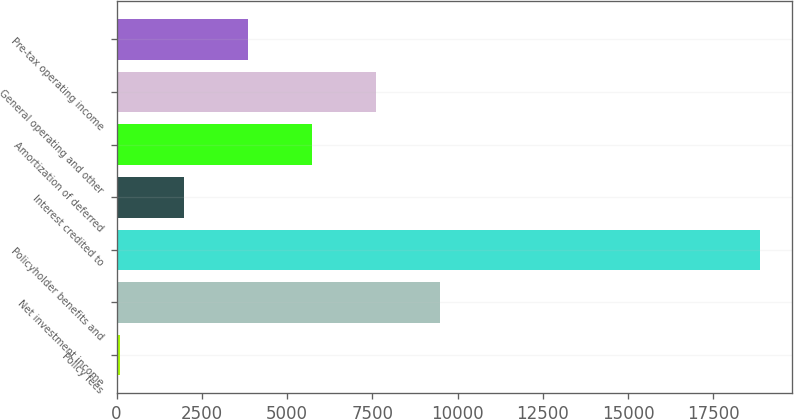<chart> <loc_0><loc_0><loc_500><loc_500><bar_chart><fcel>Policy fees<fcel>Net investment income<fcel>Policyholder benefits and<fcel>Interest credited to<fcel>Amortization of deferred<fcel>General operating and other<fcel>Pre-tax operating income<nl><fcel>102<fcel>9486<fcel>18870<fcel>1978.8<fcel>5732.4<fcel>7609.2<fcel>3855.6<nl></chart> 